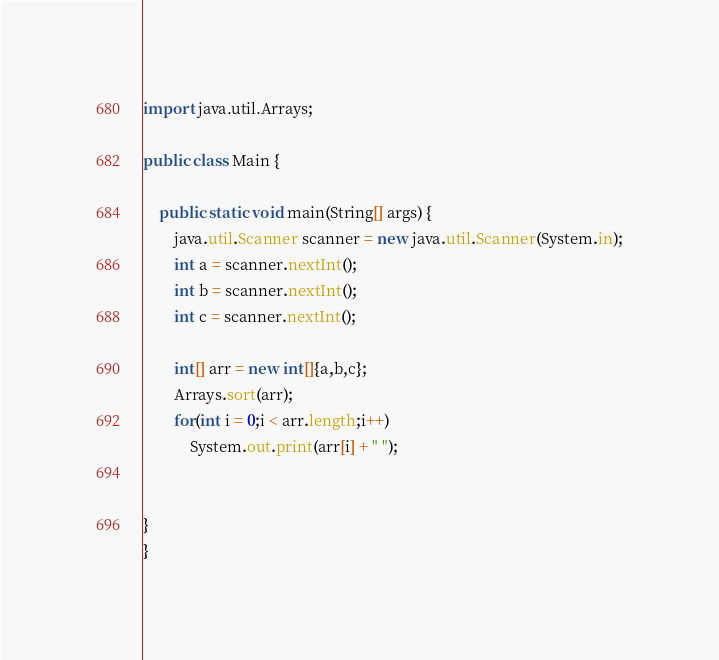Convert code to text. <code><loc_0><loc_0><loc_500><loc_500><_Java_>import java.util.Arrays;

public class Main {

	public static void main(String[] args) {
		java.util.Scanner scanner = new java.util.Scanner(System.in);
		int a = scanner.nextInt();
		int b = scanner.nextInt();
		int c = scanner.nextInt();
		
		int[] arr = new int[]{a,b,c};
		Arrays.sort(arr);
		for(int i = 0;i < arr.length;i++)
			System.out.print(arr[i] + " ");

		
}
}</code> 